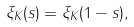<formula> <loc_0><loc_0><loc_500><loc_500>\xi _ { K } ( s ) = \xi _ { K } ( 1 - s ) ,</formula> 